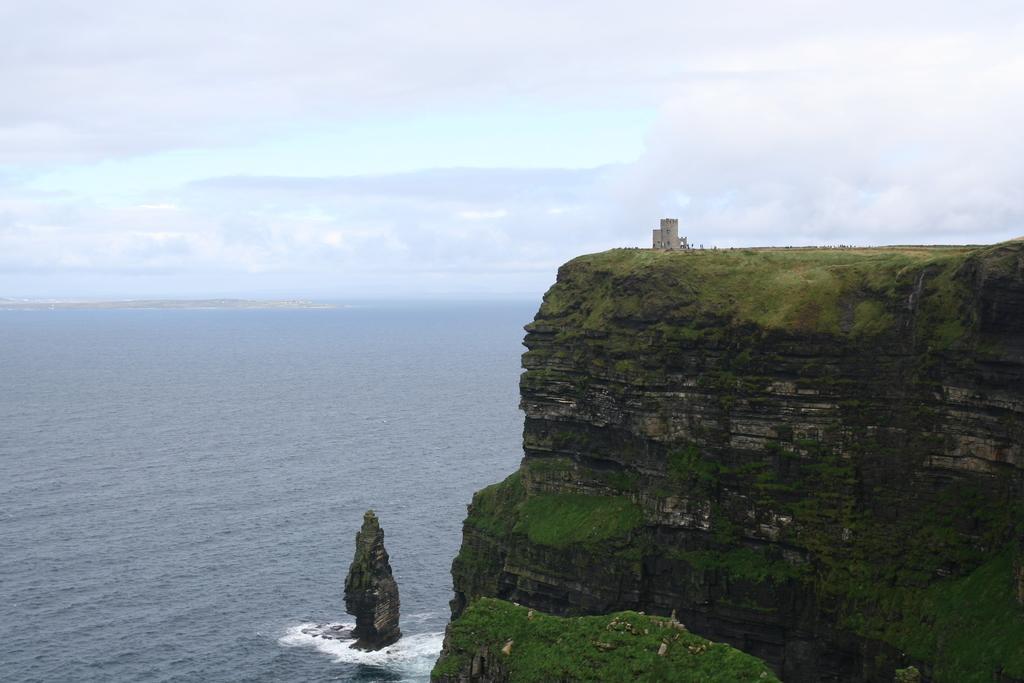In one or two sentences, can you explain what this image depicts? In this image we can see an ocean and mountain. The sky is covered with clouds. 